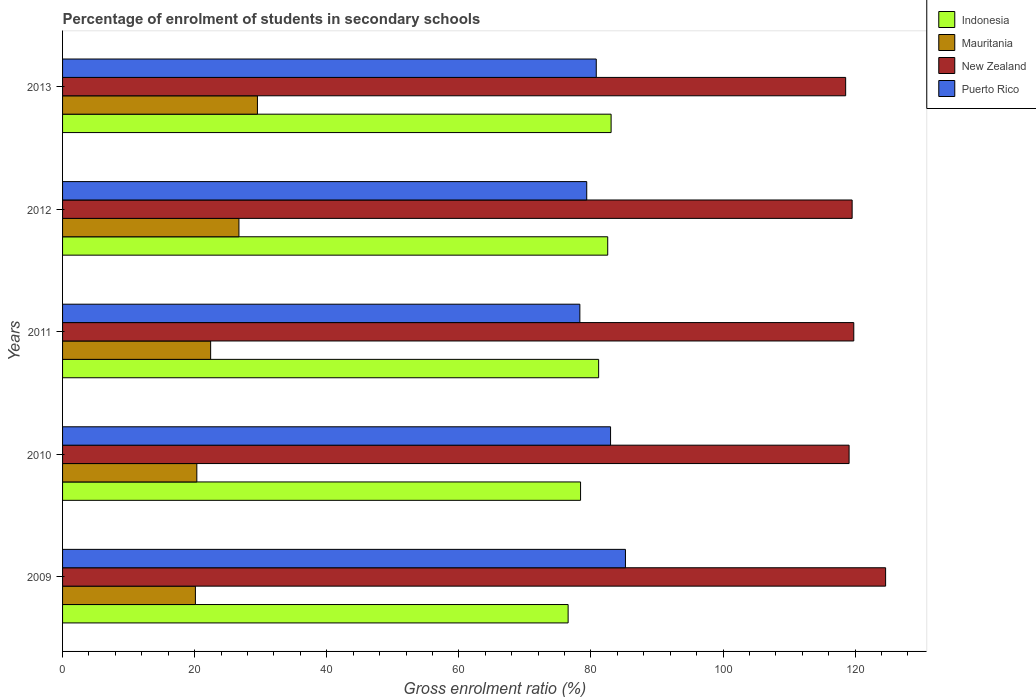How many different coloured bars are there?
Your response must be concise. 4. What is the percentage of students enrolled in secondary schools in Mauritania in 2009?
Offer a terse response. 20.11. Across all years, what is the maximum percentage of students enrolled in secondary schools in Puerto Rico?
Your answer should be very brief. 85.22. Across all years, what is the minimum percentage of students enrolled in secondary schools in New Zealand?
Keep it short and to the point. 118.56. What is the total percentage of students enrolled in secondary schools in Puerto Rico in the graph?
Give a very brief answer. 406.68. What is the difference between the percentage of students enrolled in secondary schools in New Zealand in 2011 and that in 2012?
Provide a short and direct response. 0.25. What is the difference between the percentage of students enrolled in secondary schools in Indonesia in 2010 and the percentage of students enrolled in secondary schools in Puerto Rico in 2012?
Provide a succinct answer. -0.94. What is the average percentage of students enrolled in secondary schools in Puerto Rico per year?
Provide a succinct answer. 81.34. In the year 2012, what is the difference between the percentage of students enrolled in secondary schools in Indonesia and percentage of students enrolled in secondary schools in New Zealand?
Provide a succinct answer. -37.01. In how many years, is the percentage of students enrolled in secondary schools in Puerto Rico greater than 108 %?
Make the answer very short. 0. What is the ratio of the percentage of students enrolled in secondary schools in Indonesia in 2009 to that in 2012?
Keep it short and to the point. 0.93. Is the percentage of students enrolled in secondary schools in Mauritania in 2009 less than that in 2013?
Your answer should be compact. Yes. What is the difference between the highest and the second highest percentage of students enrolled in secondary schools in Mauritania?
Your answer should be compact. 2.8. What is the difference between the highest and the lowest percentage of students enrolled in secondary schools in Puerto Rico?
Offer a very short reply. 6.9. In how many years, is the percentage of students enrolled in secondary schools in Mauritania greater than the average percentage of students enrolled in secondary schools in Mauritania taken over all years?
Provide a short and direct response. 2. Is it the case that in every year, the sum of the percentage of students enrolled in secondary schools in Mauritania and percentage of students enrolled in secondary schools in Puerto Rico is greater than the sum of percentage of students enrolled in secondary schools in Indonesia and percentage of students enrolled in secondary schools in New Zealand?
Your response must be concise. No. What does the 3rd bar from the top in 2012 represents?
Offer a terse response. Mauritania. What does the 4th bar from the bottom in 2010 represents?
Offer a very short reply. Puerto Rico. How many bars are there?
Offer a terse response. 20. How many years are there in the graph?
Offer a terse response. 5. What is the difference between two consecutive major ticks on the X-axis?
Provide a short and direct response. 20. Are the values on the major ticks of X-axis written in scientific E-notation?
Provide a succinct answer. No. Does the graph contain any zero values?
Offer a terse response. No. Does the graph contain grids?
Your response must be concise. No. How are the legend labels stacked?
Make the answer very short. Vertical. What is the title of the graph?
Give a very brief answer. Percentage of enrolment of students in secondary schools. Does "Trinidad and Tobago" appear as one of the legend labels in the graph?
Offer a terse response. No. What is the label or title of the X-axis?
Provide a short and direct response. Gross enrolment ratio (%). What is the label or title of the Y-axis?
Ensure brevity in your answer.  Years. What is the Gross enrolment ratio (%) of Indonesia in 2009?
Give a very brief answer. 76.54. What is the Gross enrolment ratio (%) in Mauritania in 2009?
Provide a succinct answer. 20.11. What is the Gross enrolment ratio (%) of New Zealand in 2009?
Your answer should be compact. 124.61. What is the Gross enrolment ratio (%) in Puerto Rico in 2009?
Provide a short and direct response. 85.22. What is the Gross enrolment ratio (%) of Indonesia in 2010?
Provide a succinct answer. 78.43. What is the Gross enrolment ratio (%) in Mauritania in 2010?
Provide a short and direct response. 20.33. What is the Gross enrolment ratio (%) of New Zealand in 2010?
Offer a very short reply. 119.08. What is the Gross enrolment ratio (%) of Puerto Rico in 2010?
Make the answer very short. 82.97. What is the Gross enrolment ratio (%) of Indonesia in 2011?
Your answer should be compact. 81.16. What is the Gross enrolment ratio (%) in Mauritania in 2011?
Offer a terse response. 22.42. What is the Gross enrolment ratio (%) in New Zealand in 2011?
Give a very brief answer. 119.79. What is the Gross enrolment ratio (%) of Puerto Rico in 2011?
Your answer should be very brief. 78.32. What is the Gross enrolment ratio (%) of Indonesia in 2012?
Give a very brief answer. 82.54. What is the Gross enrolment ratio (%) in Mauritania in 2012?
Offer a very short reply. 26.7. What is the Gross enrolment ratio (%) of New Zealand in 2012?
Your answer should be compact. 119.54. What is the Gross enrolment ratio (%) in Puerto Rico in 2012?
Provide a short and direct response. 79.36. What is the Gross enrolment ratio (%) of Indonesia in 2013?
Provide a short and direct response. 83.05. What is the Gross enrolment ratio (%) in Mauritania in 2013?
Provide a succinct answer. 29.5. What is the Gross enrolment ratio (%) in New Zealand in 2013?
Your response must be concise. 118.56. What is the Gross enrolment ratio (%) of Puerto Rico in 2013?
Keep it short and to the point. 80.8. Across all years, what is the maximum Gross enrolment ratio (%) of Indonesia?
Keep it short and to the point. 83.05. Across all years, what is the maximum Gross enrolment ratio (%) in Mauritania?
Give a very brief answer. 29.5. Across all years, what is the maximum Gross enrolment ratio (%) of New Zealand?
Provide a short and direct response. 124.61. Across all years, what is the maximum Gross enrolment ratio (%) of Puerto Rico?
Your answer should be compact. 85.22. Across all years, what is the minimum Gross enrolment ratio (%) in Indonesia?
Ensure brevity in your answer.  76.54. Across all years, what is the minimum Gross enrolment ratio (%) of Mauritania?
Provide a short and direct response. 20.11. Across all years, what is the minimum Gross enrolment ratio (%) in New Zealand?
Ensure brevity in your answer.  118.56. Across all years, what is the minimum Gross enrolment ratio (%) of Puerto Rico?
Provide a succinct answer. 78.32. What is the total Gross enrolment ratio (%) of Indonesia in the graph?
Your answer should be very brief. 401.72. What is the total Gross enrolment ratio (%) in Mauritania in the graph?
Your answer should be very brief. 119.06. What is the total Gross enrolment ratio (%) of New Zealand in the graph?
Your response must be concise. 601.59. What is the total Gross enrolment ratio (%) in Puerto Rico in the graph?
Your answer should be compact. 406.68. What is the difference between the Gross enrolment ratio (%) in Indonesia in 2009 and that in 2010?
Make the answer very short. -1.88. What is the difference between the Gross enrolment ratio (%) in Mauritania in 2009 and that in 2010?
Your answer should be very brief. -0.21. What is the difference between the Gross enrolment ratio (%) in New Zealand in 2009 and that in 2010?
Your answer should be very brief. 5.53. What is the difference between the Gross enrolment ratio (%) in Puerto Rico in 2009 and that in 2010?
Keep it short and to the point. 2.25. What is the difference between the Gross enrolment ratio (%) of Indonesia in 2009 and that in 2011?
Provide a succinct answer. -4.62. What is the difference between the Gross enrolment ratio (%) in Mauritania in 2009 and that in 2011?
Make the answer very short. -2.31. What is the difference between the Gross enrolment ratio (%) of New Zealand in 2009 and that in 2011?
Provide a succinct answer. 4.82. What is the difference between the Gross enrolment ratio (%) of Puerto Rico in 2009 and that in 2011?
Provide a short and direct response. 6.9. What is the difference between the Gross enrolment ratio (%) in Indonesia in 2009 and that in 2012?
Your answer should be very brief. -6. What is the difference between the Gross enrolment ratio (%) in Mauritania in 2009 and that in 2012?
Your answer should be very brief. -6.59. What is the difference between the Gross enrolment ratio (%) in New Zealand in 2009 and that in 2012?
Offer a terse response. 5.07. What is the difference between the Gross enrolment ratio (%) in Puerto Rico in 2009 and that in 2012?
Ensure brevity in your answer.  5.86. What is the difference between the Gross enrolment ratio (%) of Indonesia in 2009 and that in 2013?
Make the answer very short. -6.51. What is the difference between the Gross enrolment ratio (%) in Mauritania in 2009 and that in 2013?
Keep it short and to the point. -9.39. What is the difference between the Gross enrolment ratio (%) in New Zealand in 2009 and that in 2013?
Your response must be concise. 6.05. What is the difference between the Gross enrolment ratio (%) in Puerto Rico in 2009 and that in 2013?
Offer a terse response. 4.42. What is the difference between the Gross enrolment ratio (%) of Indonesia in 2010 and that in 2011?
Provide a short and direct response. -2.74. What is the difference between the Gross enrolment ratio (%) of Mauritania in 2010 and that in 2011?
Make the answer very short. -2.09. What is the difference between the Gross enrolment ratio (%) of New Zealand in 2010 and that in 2011?
Provide a short and direct response. -0.71. What is the difference between the Gross enrolment ratio (%) in Puerto Rico in 2010 and that in 2011?
Give a very brief answer. 4.65. What is the difference between the Gross enrolment ratio (%) in Indonesia in 2010 and that in 2012?
Offer a terse response. -4.11. What is the difference between the Gross enrolment ratio (%) of Mauritania in 2010 and that in 2012?
Provide a succinct answer. -6.38. What is the difference between the Gross enrolment ratio (%) of New Zealand in 2010 and that in 2012?
Make the answer very short. -0.46. What is the difference between the Gross enrolment ratio (%) in Puerto Rico in 2010 and that in 2012?
Provide a succinct answer. 3.61. What is the difference between the Gross enrolment ratio (%) in Indonesia in 2010 and that in 2013?
Give a very brief answer. -4.63. What is the difference between the Gross enrolment ratio (%) in Mauritania in 2010 and that in 2013?
Ensure brevity in your answer.  -9.18. What is the difference between the Gross enrolment ratio (%) in New Zealand in 2010 and that in 2013?
Offer a terse response. 0.52. What is the difference between the Gross enrolment ratio (%) in Puerto Rico in 2010 and that in 2013?
Offer a very short reply. 2.17. What is the difference between the Gross enrolment ratio (%) of Indonesia in 2011 and that in 2012?
Make the answer very short. -1.38. What is the difference between the Gross enrolment ratio (%) in Mauritania in 2011 and that in 2012?
Provide a succinct answer. -4.28. What is the difference between the Gross enrolment ratio (%) of New Zealand in 2011 and that in 2012?
Ensure brevity in your answer.  0.25. What is the difference between the Gross enrolment ratio (%) in Puerto Rico in 2011 and that in 2012?
Provide a short and direct response. -1.04. What is the difference between the Gross enrolment ratio (%) in Indonesia in 2011 and that in 2013?
Provide a succinct answer. -1.89. What is the difference between the Gross enrolment ratio (%) in Mauritania in 2011 and that in 2013?
Provide a short and direct response. -7.08. What is the difference between the Gross enrolment ratio (%) of New Zealand in 2011 and that in 2013?
Provide a short and direct response. 1.23. What is the difference between the Gross enrolment ratio (%) in Puerto Rico in 2011 and that in 2013?
Your answer should be very brief. -2.48. What is the difference between the Gross enrolment ratio (%) of Indonesia in 2012 and that in 2013?
Your answer should be very brief. -0.51. What is the difference between the Gross enrolment ratio (%) of Mauritania in 2012 and that in 2013?
Ensure brevity in your answer.  -2.8. What is the difference between the Gross enrolment ratio (%) in New Zealand in 2012 and that in 2013?
Ensure brevity in your answer.  0.98. What is the difference between the Gross enrolment ratio (%) in Puerto Rico in 2012 and that in 2013?
Keep it short and to the point. -1.44. What is the difference between the Gross enrolment ratio (%) of Indonesia in 2009 and the Gross enrolment ratio (%) of Mauritania in 2010?
Make the answer very short. 56.22. What is the difference between the Gross enrolment ratio (%) of Indonesia in 2009 and the Gross enrolment ratio (%) of New Zealand in 2010?
Your response must be concise. -42.54. What is the difference between the Gross enrolment ratio (%) of Indonesia in 2009 and the Gross enrolment ratio (%) of Puerto Rico in 2010?
Give a very brief answer. -6.43. What is the difference between the Gross enrolment ratio (%) of Mauritania in 2009 and the Gross enrolment ratio (%) of New Zealand in 2010?
Provide a succinct answer. -98.97. What is the difference between the Gross enrolment ratio (%) of Mauritania in 2009 and the Gross enrolment ratio (%) of Puerto Rico in 2010?
Provide a short and direct response. -62.86. What is the difference between the Gross enrolment ratio (%) of New Zealand in 2009 and the Gross enrolment ratio (%) of Puerto Rico in 2010?
Make the answer very short. 41.64. What is the difference between the Gross enrolment ratio (%) in Indonesia in 2009 and the Gross enrolment ratio (%) in Mauritania in 2011?
Provide a short and direct response. 54.12. What is the difference between the Gross enrolment ratio (%) of Indonesia in 2009 and the Gross enrolment ratio (%) of New Zealand in 2011?
Keep it short and to the point. -43.25. What is the difference between the Gross enrolment ratio (%) of Indonesia in 2009 and the Gross enrolment ratio (%) of Puerto Rico in 2011?
Your answer should be compact. -1.78. What is the difference between the Gross enrolment ratio (%) in Mauritania in 2009 and the Gross enrolment ratio (%) in New Zealand in 2011?
Your answer should be very brief. -99.68. What is the difference between the Gross enrolment ratio (%) in Mauritania in 2009 and the Gross enrolment ratio (%) in Puerto Rico in 2011?
Ensure brevity in your answer.  -58.21. What is the difference between the Gross enrolment ratio (%) in New Zealand in 2009 and the Gross enrolment ratio (%) in Puerto Rico in 2011?
Offer a very short reply. 46.29. What is the difference between the Gross enrolment ratio (%) in Indonesia in 2009 and the Gross enrolment ratio (%) in Mauritania in 2012?
Provide a succinct answer. 49.84. What is the difference between the Gross enrolment ratio (%) of Indonesia in 2009 and the Gross enrolment ratio (%) of New Zealand in 2012?
Provide a succinct answer. -43. What is the difference between the Gross enrolment ratio (%) in Indonesia in 2009 and the Gross enrolment ratio (%) in Puerto Rico in 2012?
Give a very brief answer. -2.82. What is the difference between the Gross enrolment ratio (%) of Mauritania in 2009 and the Gross enrolment ratio (%) of New Zealand in 2012?
Offer a terse response. -99.43. What is the difference between the Gross enrolment ratio (%) in Mauritania in 2009 and the Gross enrolment ratio (%) in Puerto Rico in 2012?
Ensure brevity in your answer.  -59.25. What is the difference between the Gross enrolment ratio (%) of New Zealand in 2009 and the Gross enrolment ratio (%) of Puerto Rico in 2012?
Offer a very short reply. 45.25. What is the difference between the Gross enrolment ratio (%) of Indonesia in 2009 and the Gross enrolment ratio (%) of Mauritania in 2013?
Keep it short and to the point. 47.04. What is the difference between the Gross enrolment ratio (%) of Indonesia in 2009 and the Gross enrolment ratio (%) of New Zealand in 2013?
Offer a terse response. -42.02. What is the difference between the Gross enrolment ratio (%) of Indonesia in 2009 and the Gross enrolment ratio (%) of Puerto Rico in 2013?
Make the answer very short. -4.26. What is the difference between the Gross enrolment ratio (%) in Mauritania in 2009 and the Gross enrolment ratio (%) in New Zealand in 2013?
Offer a very short reply. -98.45. What is the difference between the Gross enrolment ratio (%) of Mauritania in 2009 and the Gross enrolment ratio (%) of Puerto Rico in 2013?
Make the answer very short. -60.69. What is the difference between the Gross enrolment ratio (%) in New Zealand in 2009 and the Gross enrolment ratio (%) in Puerto Rico in 2013?
Give a very brief answer. 43.81. What is the difference between the Gross enrolment ratio (%) in Indonesia in 2010 and the Gross enrolment ratio (%) in Mauritania in 2011?
Your answer should be very brief. 56.01. What is the difference between the Gross enrolment ratio (%) in Indonesia in 2010 and the Gross enrolment ratio (%) in New Zealand in 2011?
Make the answer very short. -41.37. What is the difference between the Gross enrolment ratio (%) in Indonesia in 2010 and the Gross enrolment ratio (%) in Puerto Rico in 2011?
Keep it short and to the point. 0.11. What is the difference between the Gross enrolment ratio (%) in Mauritania in 2010 and the Gross enrolment ratio (%) in New Zealand in 2011?
Your answer should be compact. -99.47. What is the difference between the Gross enrolment ratio (%) in Mauritania in 2010 and the Gross enrolment ratio (%) in Puerto Rico in 2011?
Your answer should be very brief. -57.99. What is the difference between the Gross enrolment ratio (%) of New Zealand in 2010 and the Gross enrolment ratio (%) of Puerto Rico in 2011?
Give a very brief answer. 40.76. What is the difference between the Gross enrolment ratio (%) of Indonesia in 2010 and the Gross enrolment ratio (%) of Mauritania in 2012?
Offer a very short reply. 51.72. What is the difference between the Gross enrolment ratio (%) in Indonesia in 2010 and the Gross enrolment ratio (%) in New Zealand in 2012?
Provide a short and direct response. -41.12. What is the difference between the Gross enrolment ratio (%) in Indonesia in 2010 and the Gross enrolment ratio (%) in Puerto Rico in 2012?
Your answer should be compact. -0.94. What is the difference between the Gross enrolment ratio (%) of Mauritania in 2010 and the Gross enrolment ratio (%) of New Zealand in 2012?
Provide a short and direct response. -99.22. What is the difference between the Gross enrolment ratio (%) in Mauritania in 2010 and the Gross enrolment ratio (%) in Puerto Rico in 2012?
Provide a succinct answer. -59.04. What is the difference between the Gross enrolment ratio (%) in New Zealand in 2010 and the Gross enrolment ratio (%) in Puerto Rico in 2012?
Give a very brief answer. 39.72. What is the difference between the Gross enrolment ratio (%) in Indonesia in 2010 and the Gross enrolment ratio (%) in Mauritania in 2013?
Ensure brevity in your answer.  48.92. What is the difference between the Gross enrolment ratio (%) of Indonesia in 2010 and the Gross enrolment ratio (%) of New Zealand in 2013?
Provide a succinct answer. -40.14. What is the difference between the Gross enrolment ratio (%) of Indonesia in 2010 and the Gross enrolment ratio (%) of Puerto Rico in 2013?
Give a very brief answer. -2.38. What is the difference between the Gross enrolment ratio (%) in Mauritania in 2010 and the Gross enrolment ratio (%) in New Zealand in 2013?
Provide a short and direct response. -98.24. What is the difference between the Gross enrolment ratio (%) of Mauritania in 2010 and the Gross enrolment ratio (%) of Puerto Rico in 2013?
Provide a succinct answer. -60.48. What is the difference between the Gross enrolment ratio (%) in New Zealand in 2010 and the Gross enrolment ratio (%) in Puerto Rico in 2013?
Ensure brevity in your answer.  38.28. What is the difference between the Gross enrolment ratio (%) in Indonesia in 2011 and the Gross enrolment ratio (%) in Mauritania in 2012?
Offer a very short reply. 54.46. What is the difference between the Gross enrolment ratio (%) in Indonesia in 2011 and the Gross enrolment ratio (%) in New Zealand in 2012?
Provide a succinct answer. -38.38. What is the difference between the Gross enrolment ratio (%) of Indonesia in 2011 and the Gross enrolment ratio (%) of Puerto Rico in 2012?
Give a very brief answer. 1.8. What is the difference between the Gross enrolment ratio (%) in Mauritania in 2011 and the Gross enrolment ratio (%) in New Zealand in 2012?
Your response must be concise. -97.13. What is the difference between the Gross enrolment ratio (%) in Mauritania in 2011 and the Gross enrolment ratio (%) in Puerto Rico in 2012?
Give a very brief answer. -56.94. What is the difference between the Gross enrolment ratio (%) in New Zealand in 2011 and the Gross enrolment ratio (%) in Puerto Rico in 2012?
Give a very brief answer. 40.43. What is the difference between the Gross enrolment ratio (%) of Indonesia in 2011 and the Gross enrolment ratio (%) of Mauritania in 2013?
Your response must be concise. 51.66. What is the difference between the Gross enrolment ratio (%) in Indonesia in 2011 and the Gross enrolment ratio (%) in New Zealand in 2013?
Your answer should be very brief. -37.4. What is the difference between the Gross enrolment ratio (%) of Indonesia in 2011 and the Gross enrolment ratio (%) of Puerto Rico in 2013?
Offer a very short reply. 0.36. What is the difference between the Gross enrolment ratio (%) in Mauritania in 2011 and the Gross enrolment ratio (%) in New Zealand in 2013?
Ensure brevity in your answer.  -96.14. What is the difference between the Gross enrolment ratio (%) of Mauritania in 2011 and the Gross enrolment ratio (%) of Puerto Rico in 2013?
Your answer should be compact. -58.38. What is the difference between the Gross enrolment ratio (%) of New Zealand in 2011 and the Gross enrolment ratio (%) of Puerto Rico in 2013?
Provide a short and direct response. 38.99. What is the difference between the Gross enrolment ratio (%) of Indonesia in 2012 and the Gross enrolment ratio (%) of Mauritania in 2013?
Keep it short and to the point. 53.04. What is the difference between the Gross enrolment ratio (%) in Indonesia in 2012 and the Gross enrolment ratio (%) in New Zealand in 2013?
Ensure brevity in your answer.  -36.02. What is the difference between the Gross enrolment ratio (%) in Indonesia in 2012 and the Gross enrolment ratio (%) in Puerto Rico in 2013?
Make the answer very short. 1.74. What is the difference between the Gross enrolment ratio (%) of Mauritania in 2012 and the Gross enrolment ratio (%) of New Zealand in 2013?
Your answer should be compact. -91.86. What is the difference between the Gross enrolment ratio (%) of Mauritania in 2012 and the Gross enrolment ratio (%) of Puerto Rico in 2013?
Make the answer very short. -54.1. What is the difference between the Gross enrolment ratio (%) of New Zealand in 2012 and the Gross enrolment ratio (%) of Puerto Rico in 2013?
Ensure brevity in your answer.  38.74. What is the average Gross enrolment ratio (%) of Indonesia per year?
Give a very brief answer. 80.34. What is the average Gross enrolment ratio (%) in Mauritania per year?
Your response must be concise. 23.81. What is the average Gross enrolment ratio (%) in New Zealand per year?
Give a very brief answer. 120.32. What is the average Gross enrolment ratio (%) of Puerto Rico per year?
Your answer should be very brief. 81.34. In the year 2009, what is the difference between the Gross enrolment ratio (%) of Indonesia and Gross enrolment ratio (%) of Mauritania?
Make the answer very short. 56.43. In the year 2009, what is the difference between the Gross enrolment ratio (%) in Indonesia and Gross enrolment ratio (%) in New Zealand?
Ensure brevity in your answer.  -48.07. In the year 2009, what is the difference between the Gross enrolment ratio (%) of Indonesia and Gross enrolment ratio (%) of Puerto Rico?
Offer a terse response. -8.68. In the year 2009, what is the difference between the Gross enrolment ratio (%) of Mauritania and Gross enrolment ratio (%) of New Zealand?
Give a very brief answer. -104.5. In the year 2009, what is the difference between the Gross enrolment ratio (%) of Mauritania and Gross enrolment ratio (%) of Puerto Rico?
Offer a very short reply. -65.11. In the year 2009, what is the difference between the Gross enrolment ratio (%) of New Zealand and Gross enrolment ratio (%) of Puerto Rico?
Your answer should be very brief. 39.39. In the year 2010, what is the difference between the Gross enrolment ratio (%) of Indonesia and Gross enrolment ratio (%) of Mauritania?
Ensure brevity in your answer.  58.1. In the year 2010, what is the difference between the Gross enrolment ratio (%) in Indonesia and Gross enrolment ratio (%) in New Zealand?
Give a very brief answer. -40.66. In the year 2010, what is the difference between the Gross enrolment ratio (%) in Indonesia and Gross enrolment ratio (%) in Puerto Rico?
Provide a succinct answer. -4.54. In the year 2010, what is the difference between the Gross enrolment ratio (%) in Mauritania and Gross enrolment ratio (%) in New Zealand?
Ensure brevity in your answer.  -98.76. In the year 2010, what is the difference between the Gross enrolment ratio (%) of Mauritania and Gross enrolment ratio (%) of Puerto Rico?
Your answer should be very brief. -62.64. In the year 2010, what is the difference between the Gross enrolment ratio (%) of New Zealand and Gross enrolment ratio (%) of Puerto Rico?
Ensure brevity in your answer.  36.11. In the year 2011, what is the difference between the Gross enrolment ratio (%) in Indonesia and Gross enrolment ratio (%) in Mauritania?
Ensure brevity in your answer.  58.74. In the year 2011, what is the difference between the Gross enrolment ratio (%) of Indonesia and Gross enrolment ratio (%) of New Zealand?
Provide a short and direct response. -38.63. In the year 2011, what is the difference between the Gross enrolment ratio (%) of Indonesia and Gross enrolment ratio (%) of Puerto Rico?
Offer a terse response. 2.84. In the year 2011, what is the difference between the Gross enrolment ratio (%) in Mauritania and Gross enrolment ratio (%) in New Zealand?
Ensure brevity in your answer.  -97.37. In the year 2011, what is the difference between the Gross enrolment ratio (%) of Mauritania and Gross enrolment ratio (%) of Puerto Rico?
Provide a short and direct response. -55.9. In the year 2011, what is the difference between the Gross enrolment ratio (%) of New Zealand and Gross enrolment ratio (%) of Puerto Rico?
Your answer should be compact. 41.47. In the year 2012, what is the difference between the Gross enrolment ratio (%) in Indonesia and Gross enrolment ratio (%) in Mauritania?
Provide a short and direct response. 55.84. In the year 2012, what is the difference between the Gross enrolment ratio (%) in Indonesia and Gross enrolment ratio (%) in New Zealand?
Provide a short and direct response. -37.01. In the year 2012, what is the difference between the Gross enrolment ratio (%) of Indonesia and Gross enrolment ratio (%) of Puerto Rico?
Your answer should be compact. 3.18. In the year 2012, what is the difference between the Gross enrolment ratio (%) in Mauritania and Gross enrolment ratio (%) in New Zealand?
Keep it short and to the point. -92.84. In the year 2012, what is the difference between the Gross enrolment ratio (%) of Mauritania and Gross enrolment ratio (%) of Puerto Rico?
Your response must be concise. -52.66. In the year 2012, what is the difference between the Gross enrolment ratio (%) in New Zealand and Gross enrolment ratio (%) in Puerto Rico?
Offer a very short reply. 40.18. In the year 2013, what is the difference between the Gross enrolment ratio (%) of Indonesia and Gross enrolment ratio (%) of Mauritania?
Ensure brevity in your answer.  53.55. In the year 2013, what is the difference between the Gross enrolment ratio (%) in Indonesia and Gross enrolment ratio (%) in New Zealand?
Your response must be concise. -35.51. In the year 2013, what is the difference between the Gross enrolment ratio (%) in Indonesia and Gross enrolment ratio (%) in Puerto Rico?
Make the answer very short. 2.25. In the year 2013, what is the difference between the Gross enrolment ratio (%) of Mauritania and Gross enrolment ratio (%) of New Zealand?
Offer a very short reply. -89.06. In the year 2013, what is the difference between the Gross enrolment ratio (%) in Mauritania and Gross enrolment ratio (%) in Puerto Rico?
Your response must be concise. -51.3. In the year 2013, what is the difference between the Gross enrolment ratio (%) of New Zealand and Gross enrolment ratio (%) of Puerto Rico?
Your response must be concise. 37.76. What is the ratio of the Gross enrolment ratio (%) in New Zealand in 2009 to that in 2010?
Your answer should be compact. 1.05. What is the ratio of the Gross enrolment ratio (%) in Puerto Rico in 2009 to that in 2010?
Offer a very short reply. 1.03. What is the ratio of the Gross enrolment ratio (%) in Indonesia in 2009 to that in 2011?
Your response must be concise. 0.94. What is the ratio of the Gross enrolment ratio (%) in Mauritania in 2009 to that in 2011?
Ensure brevity in your answer.  0.9. What is the ratio of the Gross enrolment ratio (%) in New Zealand in 2009 to that in 2011?
Provide a succinct answer. 1.04. What is the ratio of the Gross enrolment ratio (%) of Puerto Rico in 2009 to that in 2011?
Provide a short and direct response. 1.09. What is the ratio of the Gross enrolment ratio (%) of Indonesia in 2009 to that in 2012?
Give a very brief answer. 0.93. What is the ratio of the Gross enrolment ratio (%) in Mauritania in 2009 to that in 2012?
Provide a succinct answer. 0.75. What is the ratio of the Gross enrolment ratio (%) of New Zealand in 2009 to that in 2012?
Make the answer very short. 1.04. What is the ratio of the Gross enrolment ratio (%) of Puerto Rico in 2009 to that in 2012?
Keep it short and to the point. 1.07. What is the ratio of the Gross enrolment ratio (%) in Indonesia in 2009 to that in 2013?
Keep it short and to the point. 0.92. What is the ratio of the Gross enrolment ratio (%) of Mauritania in 2009 to that in 2013?
Offer a terse response. 0.68. What is the ratio of the Gross enrolment ratio (%) in New Zealand in 2009 to that in 2013?
Offer a terse response. 1.05. What is the ratio of the Gross enrolment ratio (%) of Puerto Rico in 2009 to that in 2013?
Offer a terse response. 1.05. What is the ratio of the Gross enrolment ratio (%) in Indonesia in 2010 to that in 2011?
Your answer should be compact. 0.97. What is the ratio of the Gross enrolment ratio (%) of Mauritania in 2010 to that in 2011?
Your answer should be compact. 0.91. What is the ratio of the Gross enrolment ratio (%) in Puerto Rico in 2010 to that in 2011?
Your response must be concise. 1.06. What is the ratio of the Gross enrolment ratio (%) in Indonesia in 2010 to that in 2012?
Offer a terse response. 0.95. What is the ratio of the Gross enrolment ratio (%) of Mauritania in 2010 to that in 2012?
Give a very brief answer. 0.76. What is the ratio of the Gross enrolment ratio (%) in Puerto Rico in 2010 to that in 2012?
Your answer should be compact. 1.05. What is the ratio of the Gross enrolment ratio (%) in Indonesia in 2010 to that in 2013?
Keep it short and to the point. 0.94. What is the ratio of the Gross enrolment ratio (%) of Mauritania in 2010 to that in 2013?
Your answer should be very brief. 0.69. What is the ratio of the Gross enrolment ratio (%) in New Zealand in 2010 to that in 2013?
Your answer should be compact. 1. What is the ratio of the Gross enrolment ratio (%) in Puerto Rico in 2010 to that in 2013?
Make the answer very short. 1.03. What is the ratio of the Gross enrolment ratio (%) of Indonesia in 2011 to that in 2012?
Provide a succinct answer. 0.98. What is the ratio of the Gross enrolment ratio (%) in Mauritania in 2011 to that in 2012?
Your answer should be very brief. 0.84. What is the ratio of the Gross enrolment ratio (%) of Puerto Rico in 2011 to that in 2012?
Provide a succinct answer. 0.99. What is the ratio of the Gross enrolment ratio (%) of Indonesia in 2011 to that in 2013?
Your answer should be compact. 0.98. What is the ratio of the Gross enrolment ratio (%) in Mauritania in 2011 to that in 2013?
Ensure brevity in your answer.  0.76. What is the ratio of the Gross enrolment ratio (%) of New Zealand in 2011 to that in 2013?
Offer a terse response. 1.01. What is the ratio of the Gross enrolment ratio (%) in Puerto Rico in 2011 to that in 2013?
Your response must be concise. 0.97. What is the ratio of the Gross enrolment ratio (%) of Mauritania in 2012 to that in 2013?
Your answer should be very brief. 0.91. What is the ratio of the Gross enrolment ratio (%) of New Zealand in 2012 to that in 2013?
Provide a short and direct response. 1.01. What is the ratio of the Gross enrolment ratio (%) of Puerto Rico in 2012 to that in 2013?
Your answer should be compact. 0.98. What is the difference between the highest and the second highest Gross enrolment ratio (%) in Indonesia?
Ensure brevity in your answer.  0.51. What is the difference between the highest and the second highest Gross enrolment ratio (%) of Mauritania?
Provide a succinct answer. 2.8. What is the difference between the highest and the second highest Gross enrolment ratio (%) of New Zealand?
Ensure brevity in your answer.  4.82. What is the difference between the highest and the second highest Gross enrolment ratio (%) of Puerto Rico?
Provide a succinct answer. 2.25. What is the difference between the highest and the lowest Gross enrolment ratio (%) of Indonesia?
Provide a short and direct response. 6.51. What is the difference between the highest and the lowest Gross enrolment ratio (%) in Mauritania?
Offer a terse response. 9.39. What is the difference between the highest and the lowest Gross enrolment ratio (%) of New Zealand?
Your response must be concise. 6.05. What is the difference between the highest and the lowest Gross enrolment ratio (%) in Puerto Rico?
Provide a succinct answer. 6.9. 